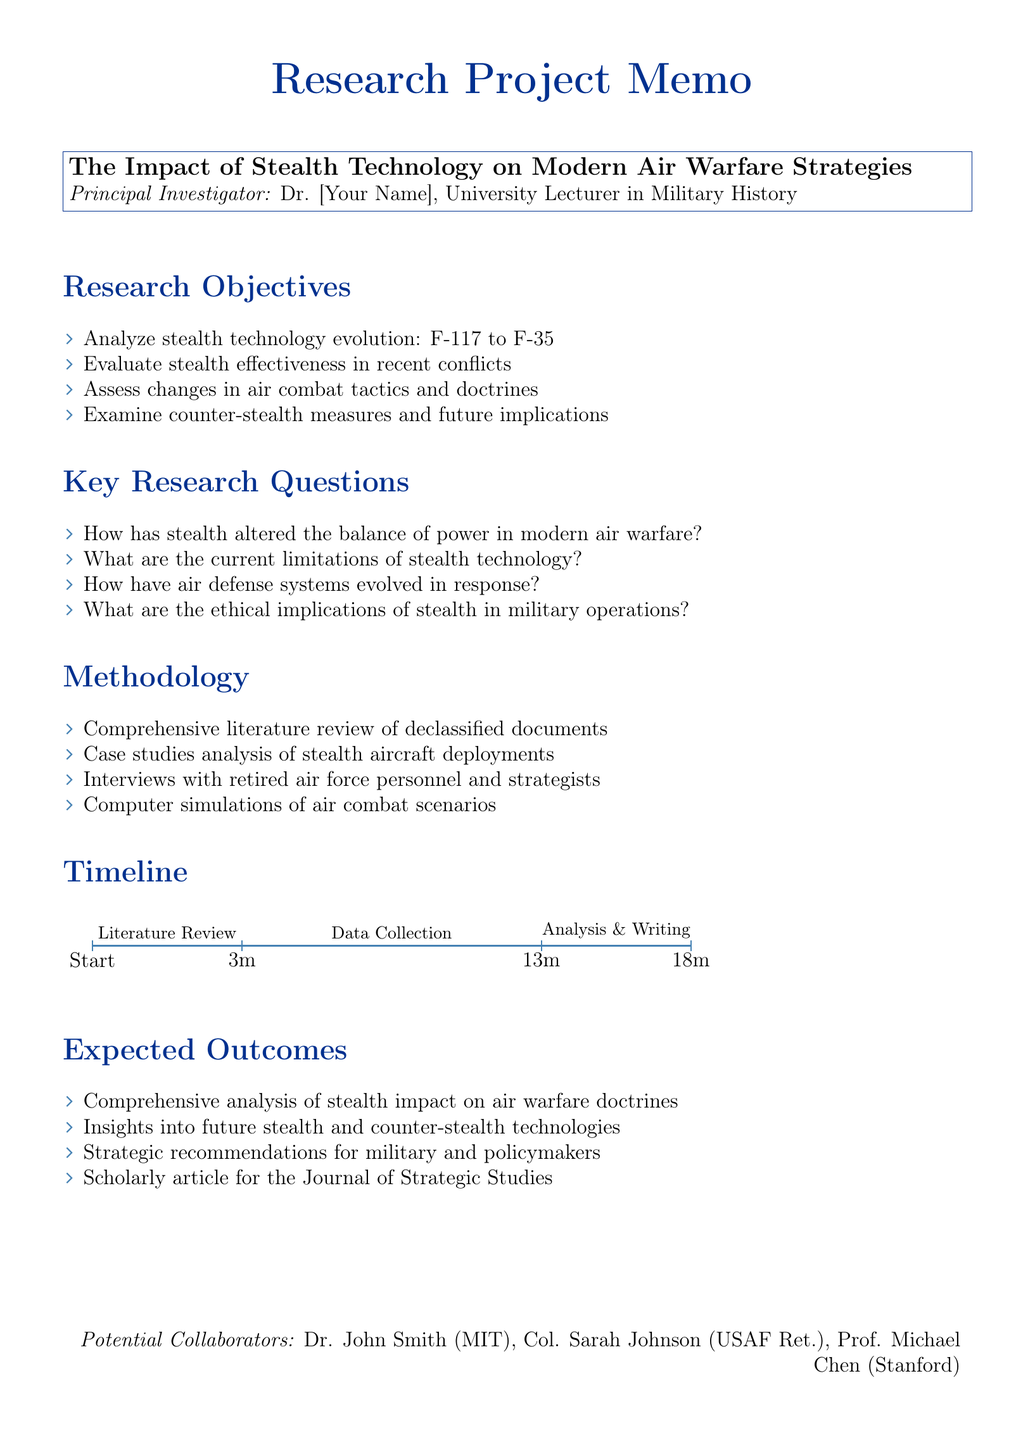What is the title of the research project? The title of the research project is stated at the beginning of the document.
Answer: The Impact of Stealth Technology on Modern Air Warfare Strategies Who is the principal investigator? The principal investigator is listed right below the project title.
Answer: Dr. [Your Name] How many months are allocated for data collection and interviews? The timeline section specifies the duration for each component of the project.
Answer: 6 months What is one of the key conflicts for analysis? The relevant sections list several conflicts to be analyzed in the project.
Answer: Gulf War (1991) What are the expected outcomes of the research project? The section on expected outcomes outlines the primary results anticipated from the research.
Answer: A comprehensive analysis of the impact of stealth technology on air warfare doctrines How many key research questions are listed? The key research questions section enumerates distinct inquiries related to the project.
Answer: 4 What methodology will be used to conduct this research? The methodology section details the approaches to be utilized in the study.
Answer: Comprehensive literature review of declassified documents Name a potential funding source for the project. The potential funding sources section lists various organizations that may provide financial support.
Answer: Department of Defense Research Grants 